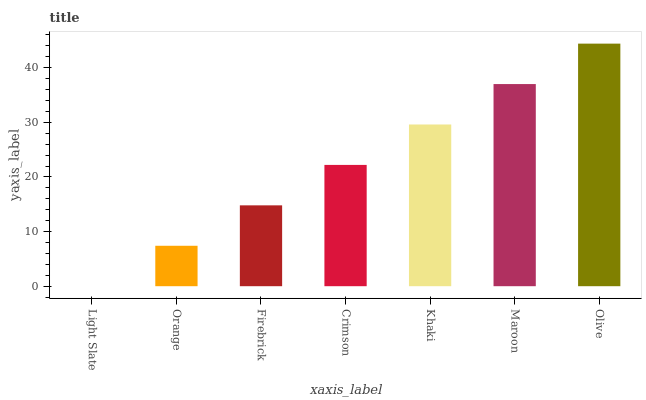Is Light Slate the minimum?
Answer yes or no. Yes. Is Olive the maximum?
Answer yes or no. Yes. Is Orange the minimum?
Answer yes or no. No. Is Orange the maximum?
Answer yes or no. No. Is Orange greater than Light Slate?
Answer yes or no. Yes. Is Light Slate less than Orange?
Answer yes or no. Yes. Is Light Slate greater than Orange?
Answer yes or no. No. Is Orange less than Light Slate?
Answer yes or no. No. Is Crimson the high median?
Answer yes or no. Yes. Is Crimson the low median?
Answer yes or no. Yes. Is Light Slate the high median?
Answer yes or no. No. Is Orange the low median?
Answer yes or no. No. 